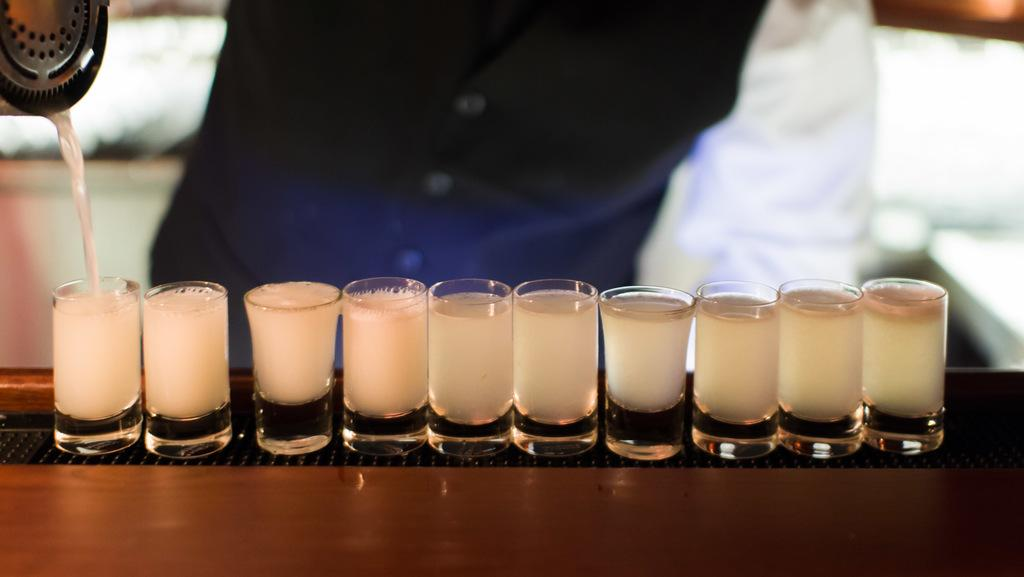What is in the glasses that are visible in the image? There are glasses with a drink in the image. What else can be seen in the image besides the glasses? There is a container in the image. Can you describe the background of the image? The background of the image is blurry. What type of fiction can be heard being read aloud in the image? There is no reference to any form of fiction or reading aloud in the image, so it's not possible to determine what, if any, fiction might be heard. 